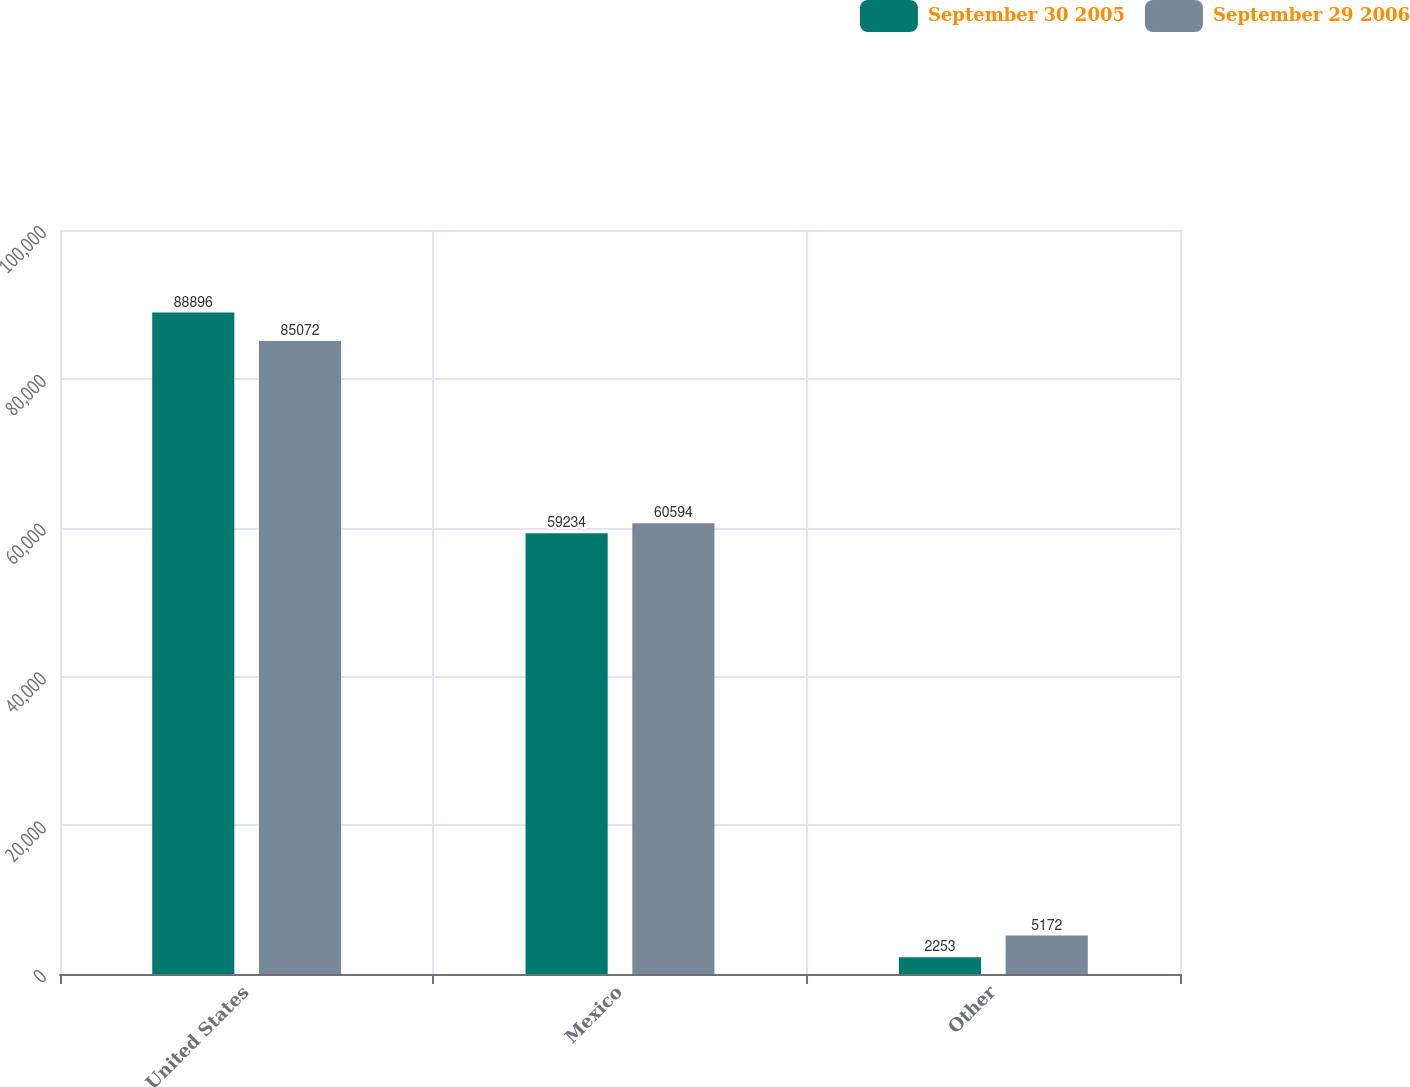Convert chart to OTSL. <chart><loc_0><loc_0><loc_500><loc_500><stacked_bar_chart><ecel><fcel>United States<fcel>Mexico<fcel>Other<nl><fcel>September 30 2005<fcel>88896<fcel>59234<fcel>2253<nl><fcel>September 29 2006<fcel>85072<fcel>60594<fcel>5172<nl></chart> 